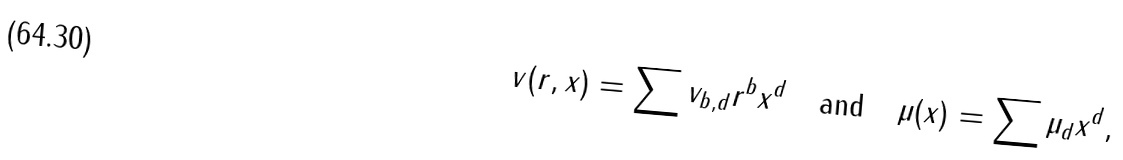Convert formula to latex. <formula><loc_0><loc_0><loc_500><loc_500>v ( r , x ) = \sum v _ { b , d } r ^ { b } x ^ { d } \quad \text {and} \quad \mu ( x ) = \sum \mu _ { d } x ^ { d } ,</formula> 